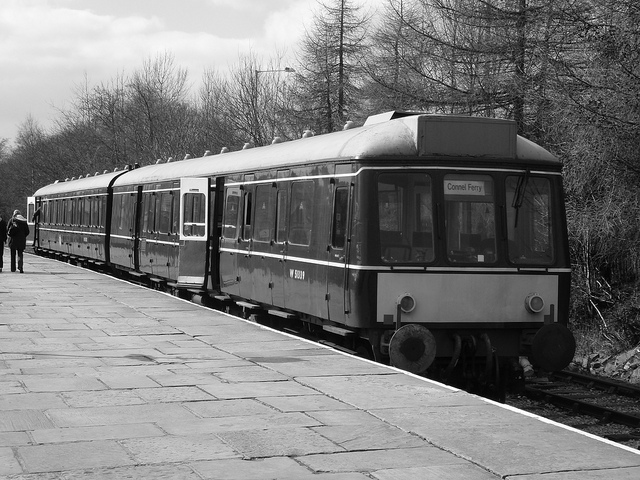<image>What does the sign on the front of the train say? It is ambiguous what the sign on the front of the train says because it can't be seen clearly. It could say 'general fax', 'covered rey', 'carnival ferry', 'carved fairy', 'canal fera', 'corel ferry', 'coral ferax', or 'connell fergie'. What does the sign on the front of the train say? The sign on the front of the train is not visible in the image. 